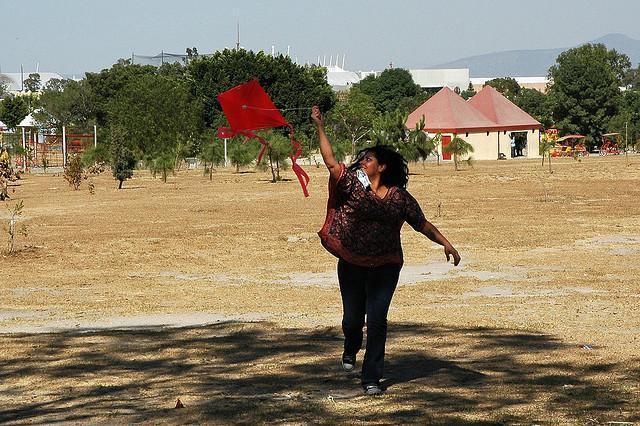How many cars are in the intersection?
Give a very brief answer. 0. 